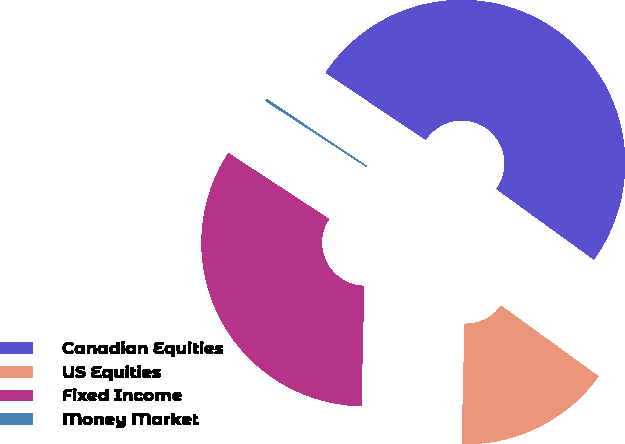Convert chart. <chart><loc_0><loc_0><loc_500><loc_500><pie_chart><fcel>Canadian Equities<fcel>US Equities<fcel>Fixed Income<fcel>Money Market<nl><fcel>50.59%<fcel>15.41%<fcel>33.84%<fcel>0.17%<nl></chart> 